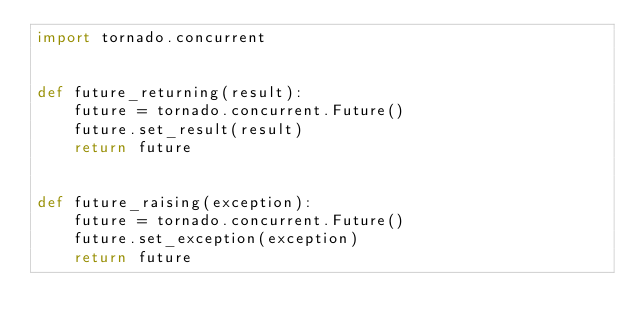<code> <loc_0><loc_0><loc_500><loc_500><_Python_>import tornado.concurrent


def future_returning(result):
    future = tornado.concurrent.Future()
    future.set_result(result)
    return future


def future_raising(exception):
    future = tornado.concurrent.Future()
    future.set_exception(exception)
    return future
</code> 